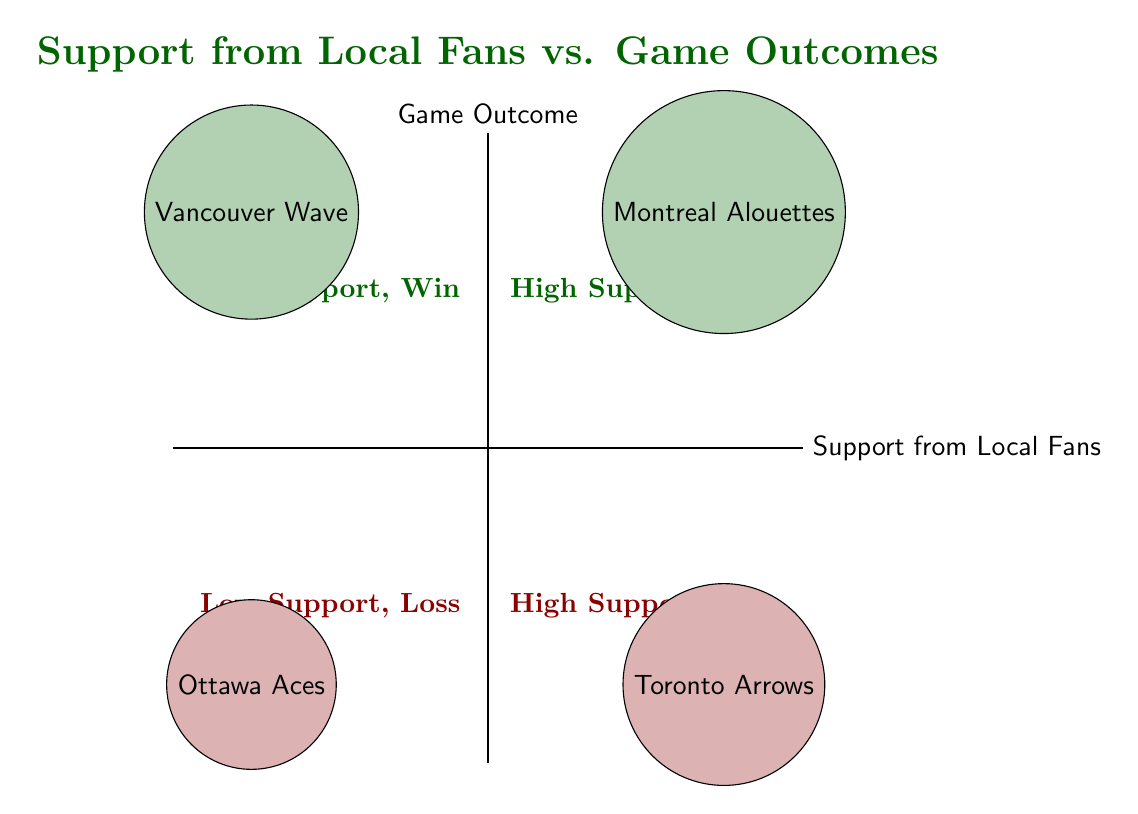What teams are in the High Support, Win quadrant? The High Support, Win quadrant includes teams that received strong local support and achieved victories in their games. By examining the diagram, the teams listed in this quadrant are the Montreal Alouettes and Vancouver Wave.
Answer: Montreal Alouettes, Vancouver Wave How many teams lost with High Support? The diagram categorically groups teams based on their support and outcome. In the High Support, Loss quadrant, there's one team mentioned, which is the Toronto Arrows. Thus, only one team fits this criteria.
Answer: 1 Which quadrant contains the Ottawa Aces? To find the Ottawa Aces, we need to check the Loss category paired with Low Support. According to the diagram, the Ottawa Aces are located in the Low Support, Loss quadrant.
Answer: Low Support, Loss What is the relationship between local support and game outcomes for the Vancouver Wave? The Vancouver Wave is located in the Low Support, Win quadrant, suggesting that they won their game despite having minimal fan support. This indicates that strong local support is not always necessary for a victory.
Answer: Low Support, Win Which team lost but had a win outcome? By inspecting the diagram, we identify that no teams fit the description of losing while demonstrating a win outcome, as outcomes are mutually exclusive in the context of sports. Therefore, this category yields no teams.
Answer: None 